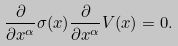<formula> <loc_0><loc_0><loc_500><loc_500>\frac { \partial } { \partial x ^ { \alpha } } \sigma ( x ) \frac { \partial } { \partial x ^ { \alpha } } V ( x ) = 0 .</formula> 